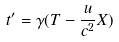<formula> <loc_0><loc_0><loc_500><loc_500>t ^ { \prime } = \gamma ( T - \frac { u } { c ^ { 2 } } X )</formula> 